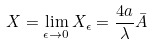Convert formula to latex. <formula><loc_0><loc_0><loc_500><loc_500>X = \lim _ { \epsilon \rightarrow 0 } X _ { \epsilon } = \frac { 4 a } { \lambda } \bar { A }</formula> 